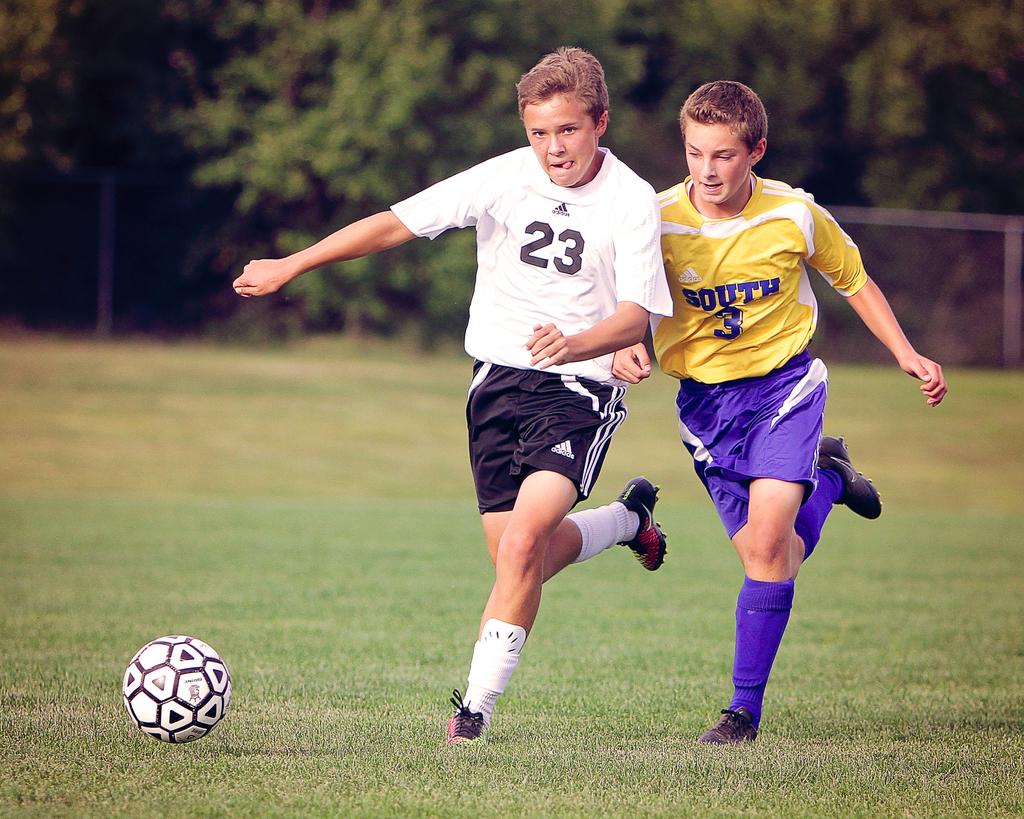Which player number is closer to the soccer ball?
Offer a very short reply. 23. What direction is the yellow shirted player wearing?
Your answer should be compact. South. 